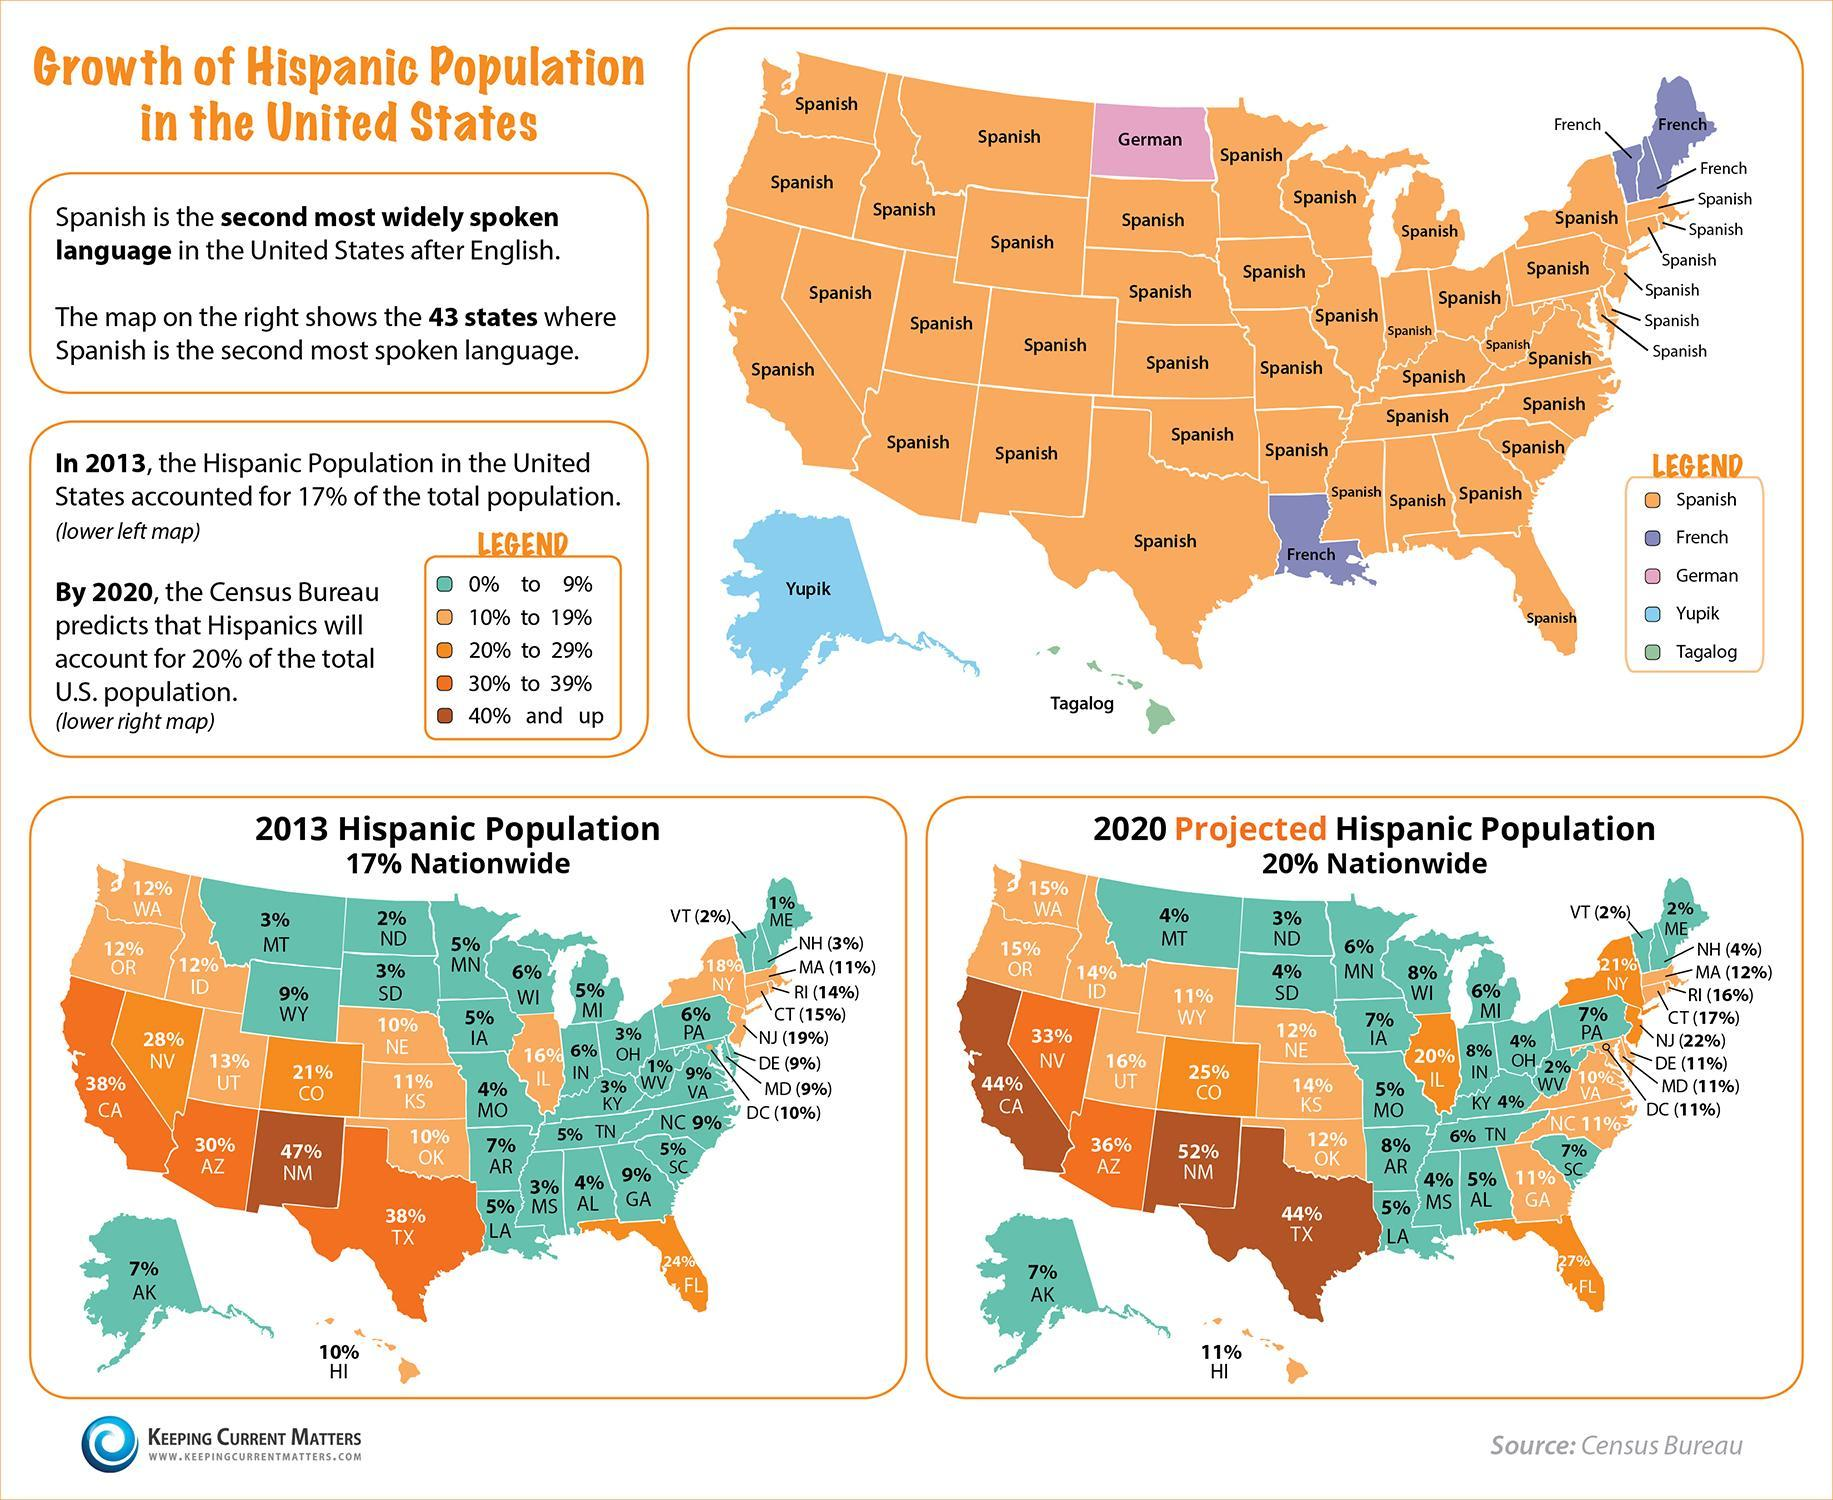Which language is the most used language besides English in Hawaii?
Answer the question with a short phrase. Tagalog In 2020, how many states are projected to have a Hispanic population between 30% and 39%? 2 What is the percent of Hispanic population in the state of Texas in 2013? 38% In how many states is French the second most widely used language? 4 Which is the second most widely used language besides English in the state of Alaska? Yupik In how many states German is the second most spoken language after English? 1 in 2013 how many states had 1% Hispanic population? 2 In 2013 how many states had Hispanic population between 20% and 29%? 3 By 2020 how many states are projected to have a Hispanic population above 40% 3 How many states have a Hispanic population above 40% in 2013? 1 